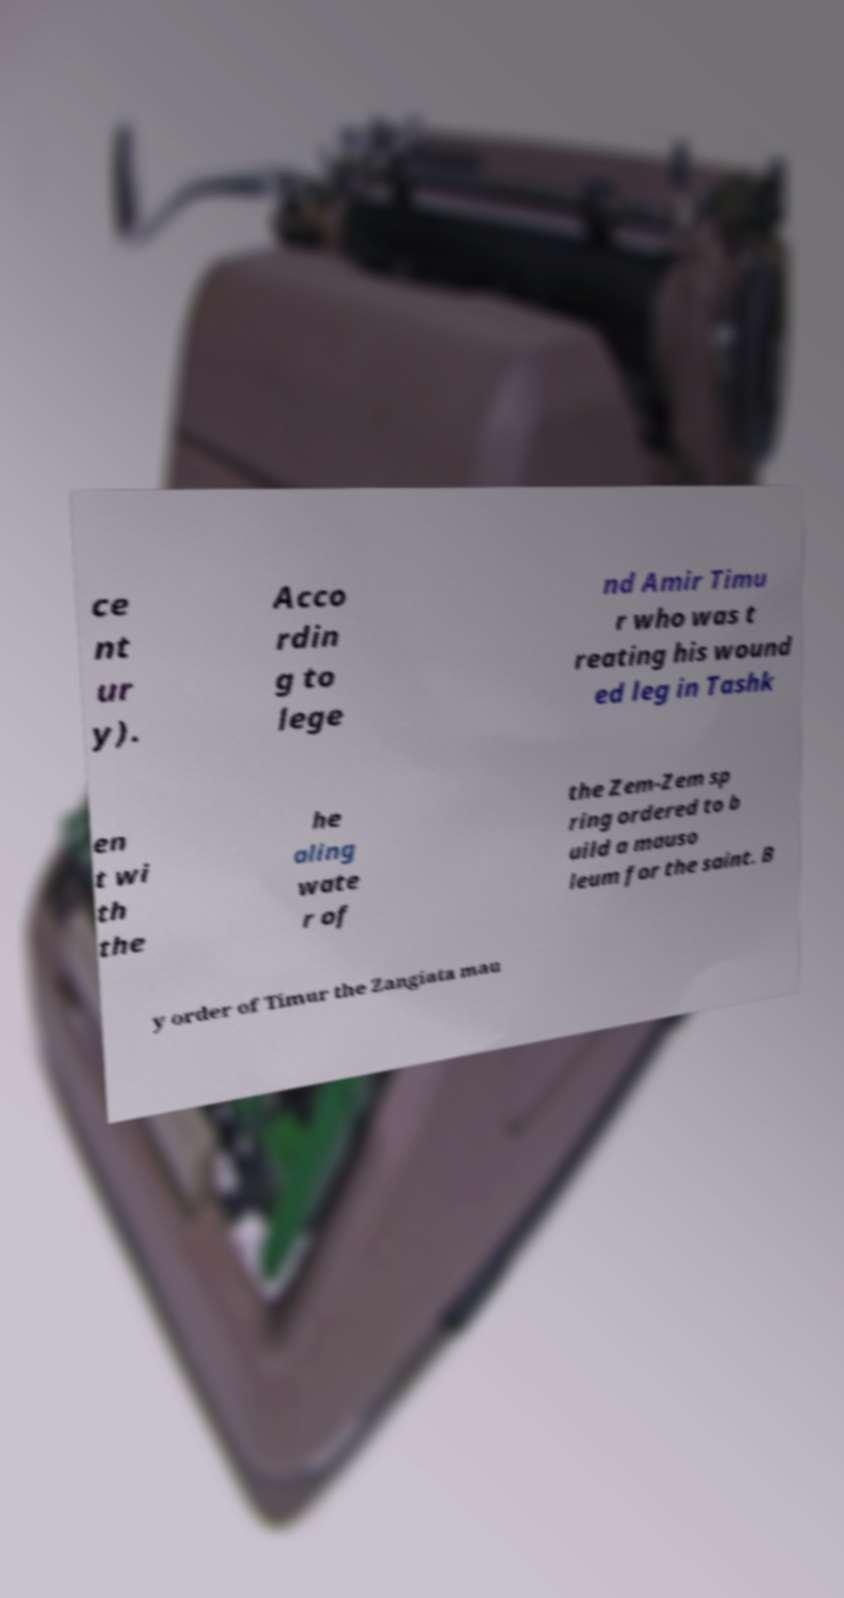Could you assist in decoding the text presented in this image and type it out clearly? ce nt ur y). Acco rdin g to lege nd Amir Timu r who was t reating his wound ed leg in Tashk en t wi th the he aling wate r of the Zem-Zem sp ring ordered to b uild a mauso leum for the saint. B y order of Timur the Zangiata mau 